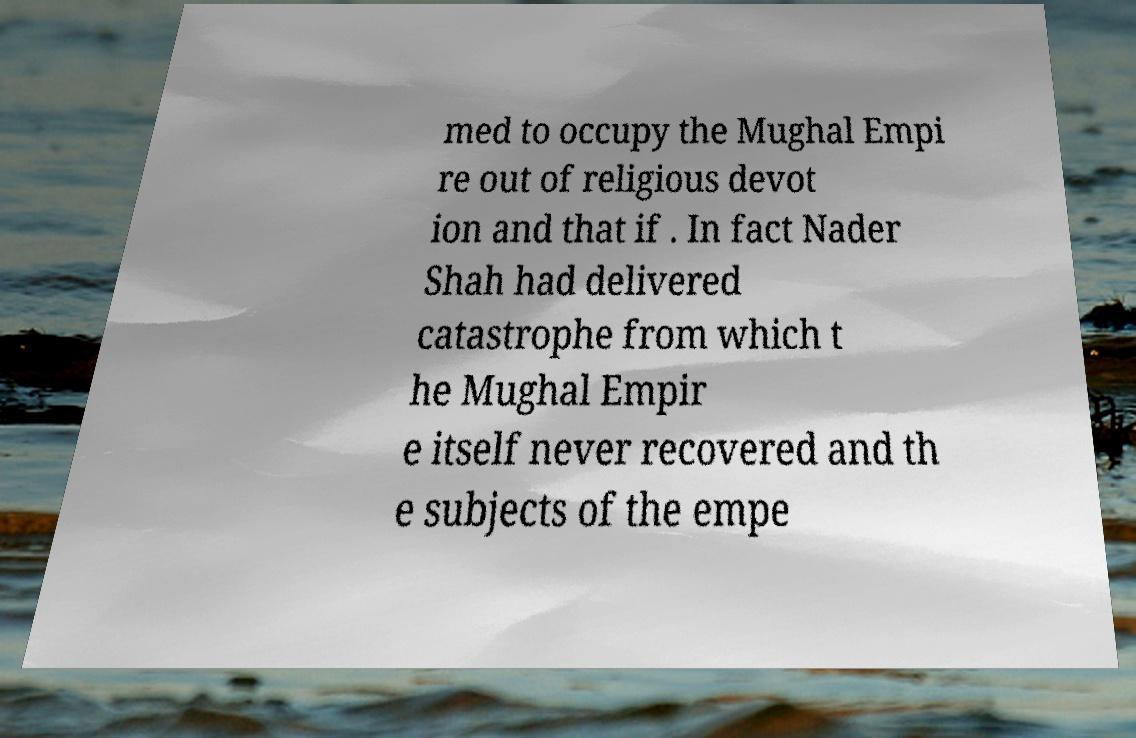For documentation purposes, I need the text within this image transcribed. Could you provide that? med to occupy the Mughal Empi re out of religious devot ion and that if . In fact Nader Shah had delivered catastrophe from which t he Mughal Empir e itself never recovered and th e subjects of the empe 